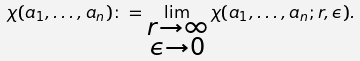<formula> <loc_0><loc_0><loc_500><loc_500>\chi ( a _ { 1 } , \dots , a _ { n } ) \colon = \lim _ { \substack { r \rightarrow \infty \\ \epsilon \rightarrow 0 } } \chi ( a _ { 1 } , \dots , a _ { n } ; r , \epsilon ) .</formula> 